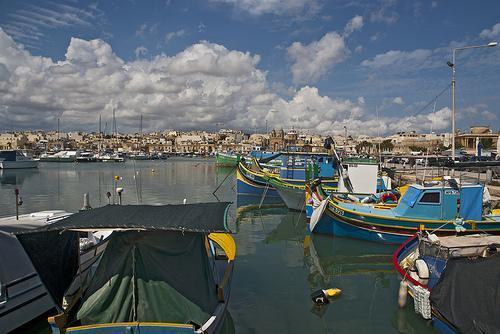How many street lights are there?
Give a very brief answer. 1. 